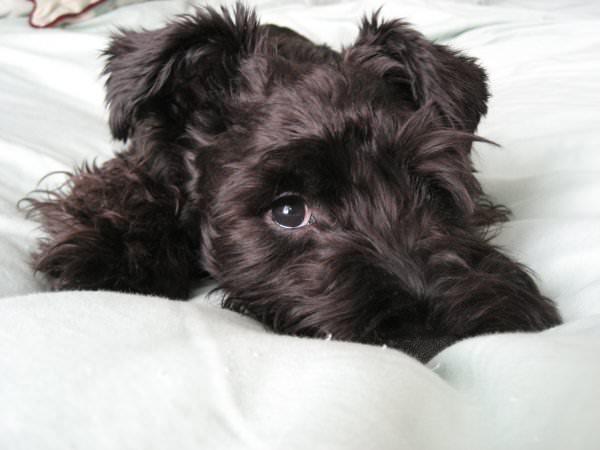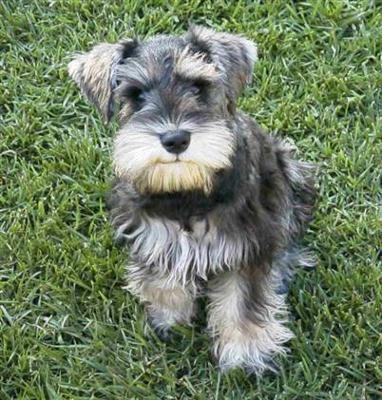The first image is the image on the left, the second image is the image on the right. For the images shown, is this caption "In one image there is a dog outside with some grass in the image." true? Answer yes or no. Yes. The first image is the image on the left, the second image is the image on the right. Given the left and right images, does the statement "There is an expanse of green grass in one dog image." hold true? Answer yes or no. Yes. The first image is the image on the left, the second image is the image on the right. For the images displayed, is the sentence "There is one image of a mostly black dog and one of at least one gray dog." factually correct? Answer yes or no. Yes. The first image is the image on the left, the second image is the image on the right. Analyze the images presented: Is the assertion "There is grass visible on one of the images." valid? Answer yes or no. Yes. 